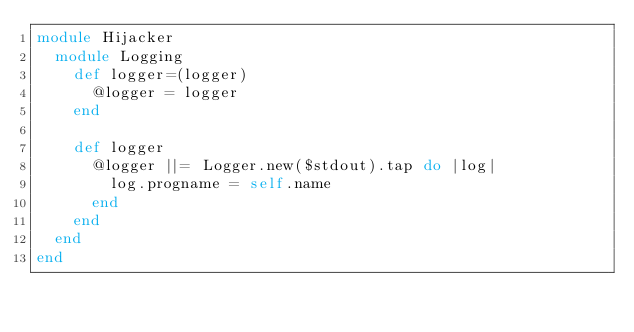Convert code to text. <code><loc_0><loc_0><loc_500><loc_500><_Ruby_>module Hijacker
  module Logging
    def logger=(logger)
      @logger = logger
    end

    def logger
      @logger ||= Logger.new($stdout).tap do |log|
        log.progname = self.name
      end
    end
  end
end
</code> 